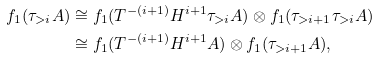Convert formula to latex. <formula><loc_0><loc_0><loc_500><loc_500>f _ { 1 } ( \tau _ { > i } A ) & \cong f _ { 1 } ( T ^ { - ( i + 1 ) } H ^ { i + 1 } \tau _ { > i } A ) \otimes f _ { 1 } ( \tau _ { > i + 1 } \tau _ { > i } A ) \\ & \cong f _ { 1 } ( T ^ { - ( i + 1 ) } H ^ { i + 1 } A ) \otimes f _ { 1 } ( \tau _ { > i + 1 } A ) ,</formula> 